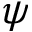<formula> <loc_0><loc_0><loc_500><loc_500>\psi</formula> 